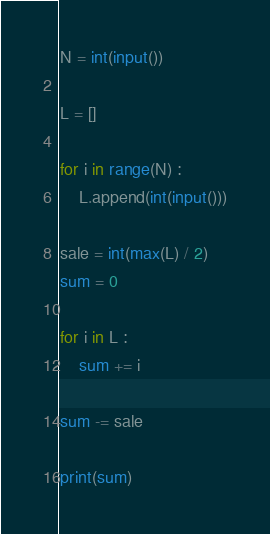Convert code to text. <code><loc_0><loc_0><loc_500><loc_500><_Python_>N = int(input())

L = []

for i in range(N) : 
    L.append(int(input()))

sale = int(max(L) / 2)
sum = 0

for i in L : 
    sum += i
    
sum -= sale

print(sum)</code> 